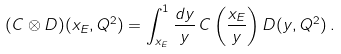<formula> <loc_0><loc_0><loc_500><loc_500>( C \otimes D ) ( x _ { E } , Q ^ { 2 } ) = \int ^ { 1 } _ { x _ { E } } \frac { d y } { y } \, C \left ( \frac { x _ { E } } { y } \right ) D ( y , Q ^ { 2 } ) \, .</formula> 